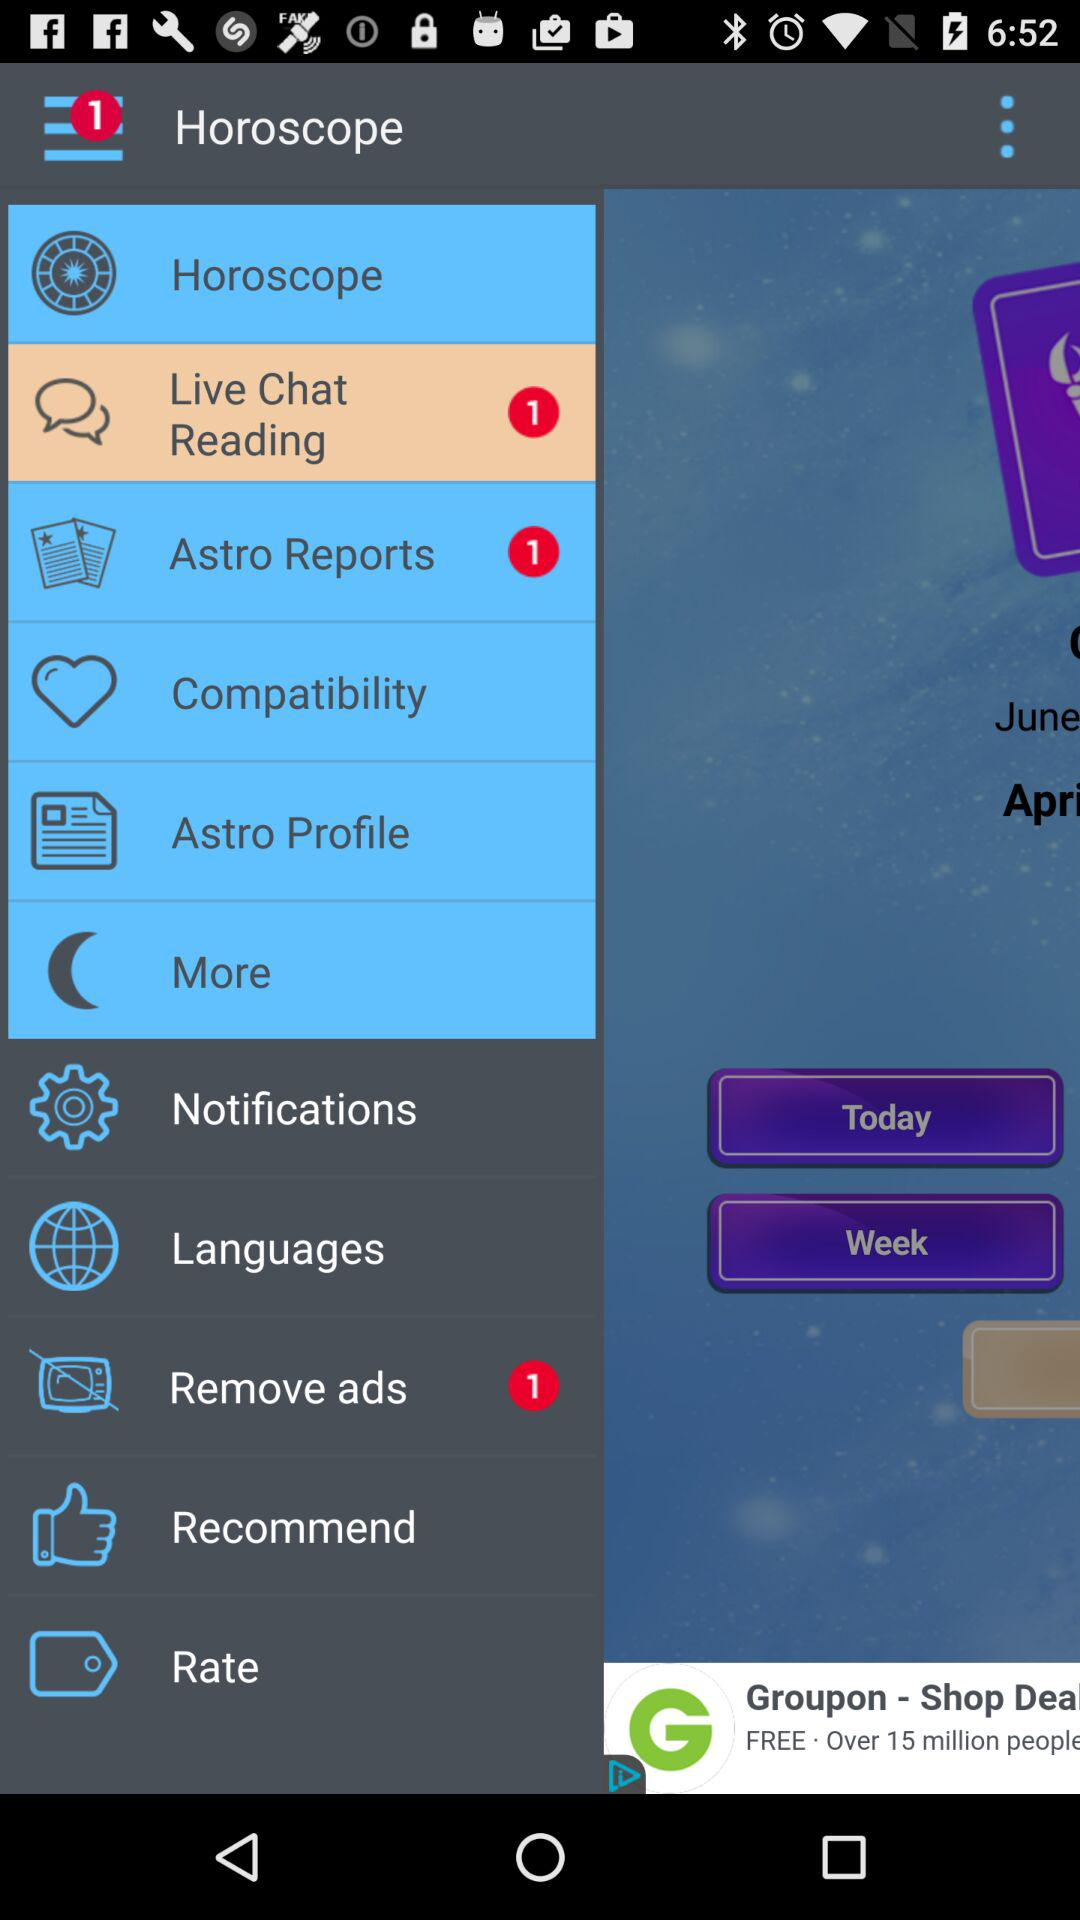How many unseen live chats are there? There is 1 unseen live chat. 